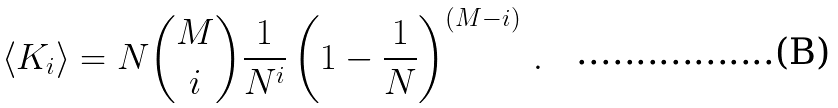<formula> <loc_0><loc_0><loc_500><loc_500>\langle K _ { i } \rangle = N \binom { M } { i } \frac { 1 } { N ^ { i } } \left ( 1 - \frac { 1 } { N } \right ) ^ { ( M - i ) } \, .</formula> 